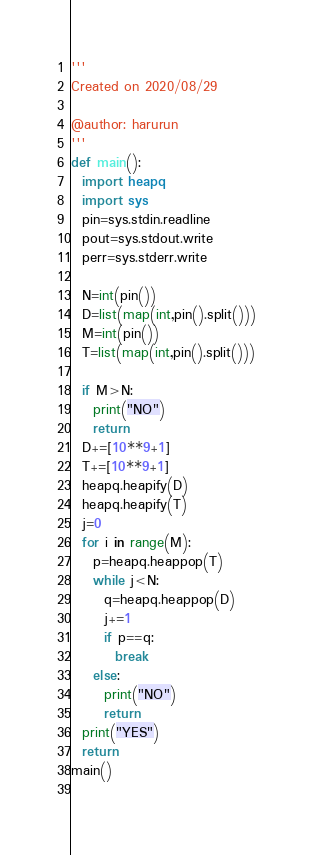<code> <loc_0><loc_0><loc_500><loc_500><_Python_>'''
Created on 2020/08/29

@author: harurun
'''
def main():
  import heapq
  import sys
  pin=sys.stdin.readline
  pout=sys.stdout.write
  perr=sys.stderr.write
  
  N=int(pin())
  D=list(map(int,pin().split()))
  M=int(pin())
  T=list(map(int,pin().split()))
  
  if M>N:
    print("NO")
    return 
  D+=[10**9+1]
  T+=[10**9+1]
  heapq.heapify(D)
  heapq.heapify(T)
  j=0
  for i in range(M):
    p=heapq.heappop(T)
    while j<N:
      q=heapq.heappop(D)
      j+=1
      if p==q:
        break
    else:
      print("NO")
      return 
  print("YES")
  return 
main()
      </code> 